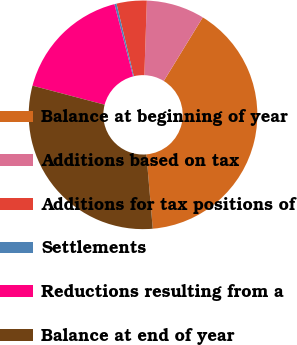<chart> <loc_0><loc_0><loc_500><loc_500><pie_chart><fcel>Balance at beginning of year<fcel>Additions based on tax<fcel>Additions for tax positions of<fcel>Settlements<fcel>Reductions resulting from a<fcel>Balance at end of year<nl><fcel>39.89%<fcel>8.22%<fcel>4.26%<fcel>0.3%<fcel>16.87%<fcel>30.46%<nl></chart> 